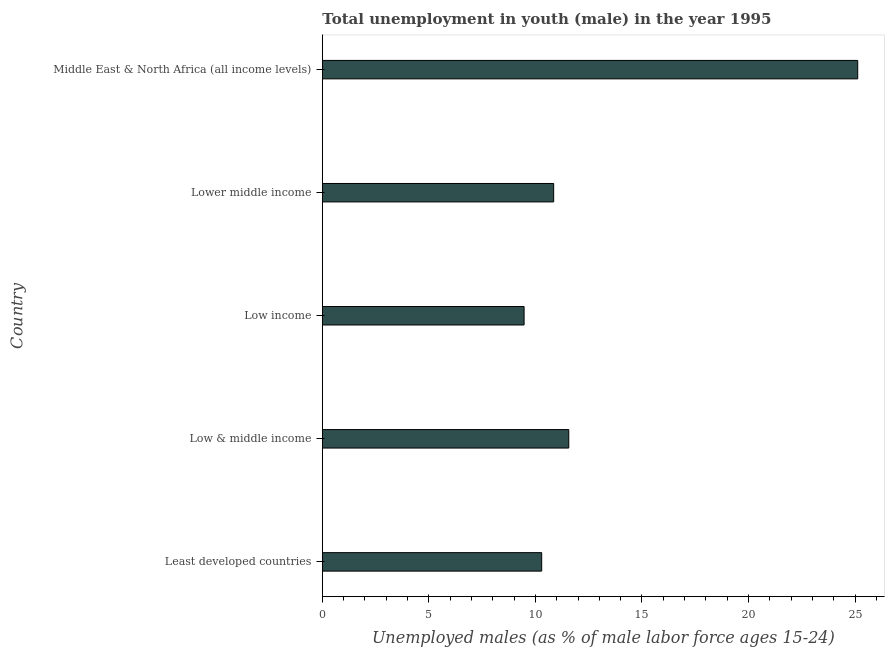Does the graph contain any zero values?
Provide a succinct answer. No. What is the title of the graph?
Your answer should be very brief. Total unemployment in youth (male) in the year 1995. What is the label or title of the X-axis?
Ensure brevity in your answer.  Unemployed males (as % of male labor force ages 15-24). What is the unemployed male youth population in Lower middle income?
Offer a terse response. 10.86. Across all countries, what is the maximum unemployed male youth population?
Your response must be concise. 25.13. Across all countries, what is the minimum unemployed male youth population?
Your response must be concise. 9.47. In which country was the unemployed male youth population maximum?
Provide a succinct answer. Middle East & North Africa (all income levels). In which country was the unemployed male youth population minimum?
Provide a short and direct response. Low income. What is the sum of the unemployed male youth population?
Give a very brief answer. 67.32. What is the difference between the unemployed male youth population in Low & middle income and Lower middle income?
Ensure brevity in your answer.  0.71. What is the average unemployed male youth population per country?
Keep it short and to the point. 13.46. What is the median unemployed male youth population?
Offer a very short reply. 10.86. In how many countries, is the unemployed male youth population greater than 3 %?
Ensure brevity in your answer.  5. What is the ratio of the unemployed male youth population in Least developed countries to that in Middle East & North Africa (all income levels)?
Your answer should be compact. 0.41. What is the difference between the highest and the second highest unemployed male youth population?
Ensure brevity in your answer.  13.56. What is the difference between the highest and the lowest unemployed male youth population?
Make the answer very short. 15.66. Are all the bars in the graph horizontal?
Keep it short and to the point. Yes. How many countries are there in the graph?
Give a very brief answer. 5. What is the difference between two consecutive major ticks on the X-axis?
Offer a terse response. 5. Are the values on the major ticks of X-axis written in scientific E-notation?
Your answer should be very brief. No. What is the Unemployed males (as % of male labor force ages 15-24) in Least developed countries?
Your response must be concise. 10.3. What is the Unemployed males (as % of male labor force ages 15-24) of Low & middle income?
Offer a terse response. 11.57. What is the Unemployed males (as % of male labor force ages 15-24) in Low income?
Your answer should be very brief. 9.47. What is the Unemployed males (as % of male labor force ages 15-24) in Lower middle income?
Make the answer very short. 10.86. What is the Unemployed males (as % of male labor force ages 15-24) of Middle East & North Africa (all income levels)?
Offer a very short reply. 25.13. What is the difference between the Unemployed males (as % of male labor force ages 15-24) in Least developed countries and Low & middle income?
Keep it short and to the point. -1.27. What is the difference between the Unemployed males (as % of male labor force ages 15-24) in Least developed countries and Low income?
Keep it short and to the point. 0.83. What is the difference between the Unemployed males (as % of male labor force ages 15-24) in Least developed countries and Lower middle income?
Ensure brevity in your answer.  -0.56. What is the difference between the Unemployed males (as % of male labor force ages 15-24) in Least developed countries and Middle East & North Africa (all income levels)?
Give a very brief answer. -14.83. What is the difference between the Unemployed males (as % of male labor force ages 15-24) in Low & middle income and Low income?
Ensure brevity in your answer.  2.1. What is the difference between the Unemployed males (as % of male labor force ages 15-24) in Low & middle income and Lower middle income?
Make the answer very short. 0.71. What is the difference between the Unemployed males (as % of male labor force ages 15-24) in Low & middle income and Middle East & North Africa (all income levels)?
Your response must be concise. -13.56. What is the difference between the Unemployed males (as % of male labor force ages 15-24) in Low income and Lower middle income?
Make the answer very short. -1.39. What is the difference between the Unemployed males (as % of male labor force ages 15-24) in Low income and Middle East & North Africa (all income levels)?
Offer a terse response. -15.66. What is the difference between the Unemployed males (as % of male labor force ages 15-24) in Lower middle income and Middle East & North Africa (all income levels)?
Your answer should be compact. -14.27. What is the ratio of the Unemployed males (as % of male labor force ages 15-24) in Least developed countries to that in Low & middle income?
Make the answer very short. 0.89. What is the ratio of the Unemployed males (as % of male labor force ages 15-24) in Least developed countries to that in Low income?
Offer a very short reply. 1.09. What is the ratio of the Unemployed males (as % of male labor force ages 15-24) in Least developed countries to that in Lower middle income?
Provide a short and direct response. 0.95. What is the ratio of the Unemployed males (as % of male labor force ages 15-24) in Least developed countries to that in Middle East & North Africa (all income levels)?
Provide a succinct answer. 0.41. What is the ratio of the Unemployed males (as % of male labor force ages 15-24) in Low & middle income to that in Low income?
Offer a terse response. 1.22. What is the ratio of the Unemployed males (as % of male labor force ages 15-24) in Low & middle income to that in Lower middle income?
Your answer should be compact. 1.06. What is the ratio of the Unemployed males (as % of male labor force ages 15-24) in Low & middle income to that in Middle East & North Africa (all income levels)?
Offer a very short reply. 0.46. What is the ratio of the Unemployed males (as % of male labor force ages 15-24) in Low income to that in Lower middle income?
Make the answer very short. 0.87. What is the ratio of the Unemployed males (as % of male labor force ages 15-24) in Low income to that in Middle East & North Africa (all income levels)?
Ensure brevity in your answer.  0.38. What is the ratio of the Unemployed males (as % of male labor force ages 15-24) in Lower middle income to that in Middle East & North Africa (all income levels)?
Provide a succinct answer. 0.43. 